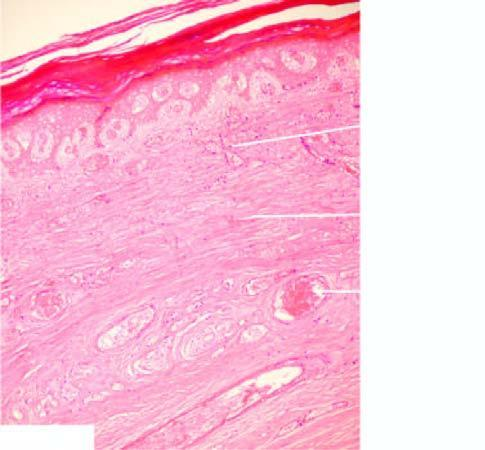does microscopy show coagulativenecrosis of the skin, muscle and other soft tissue, and thrombsed vessels?
Answer the question using a single word or phrase. Yes 